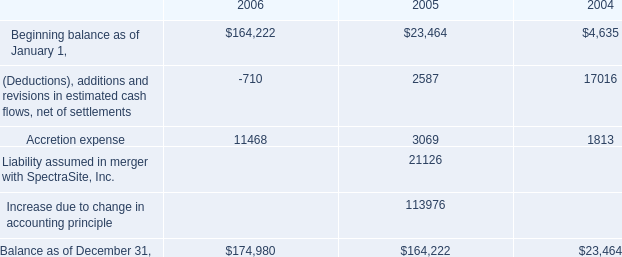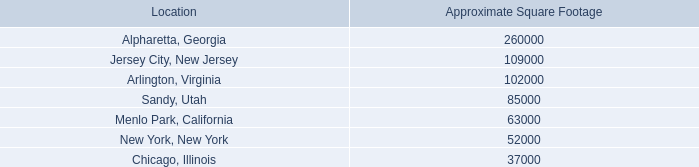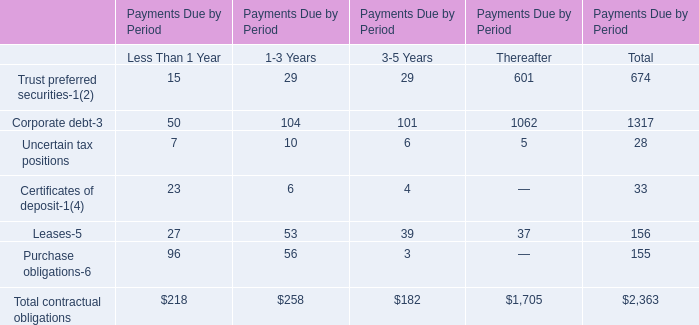Towards the kind of contractual obligations with the highest Payments Due for Less Than 1 Year, what is the Payments Due for 3-5 Years? 
Answer: 3. 